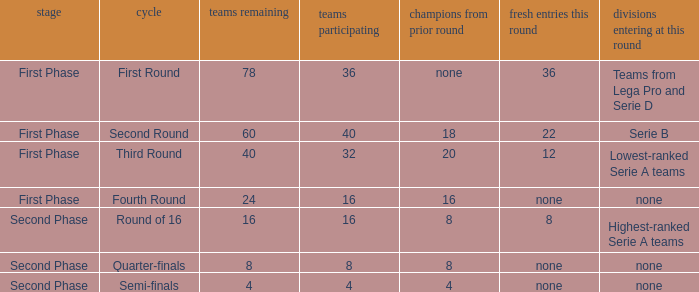From the round name of third round; what would the new entries this round that would be found? 12.0. 